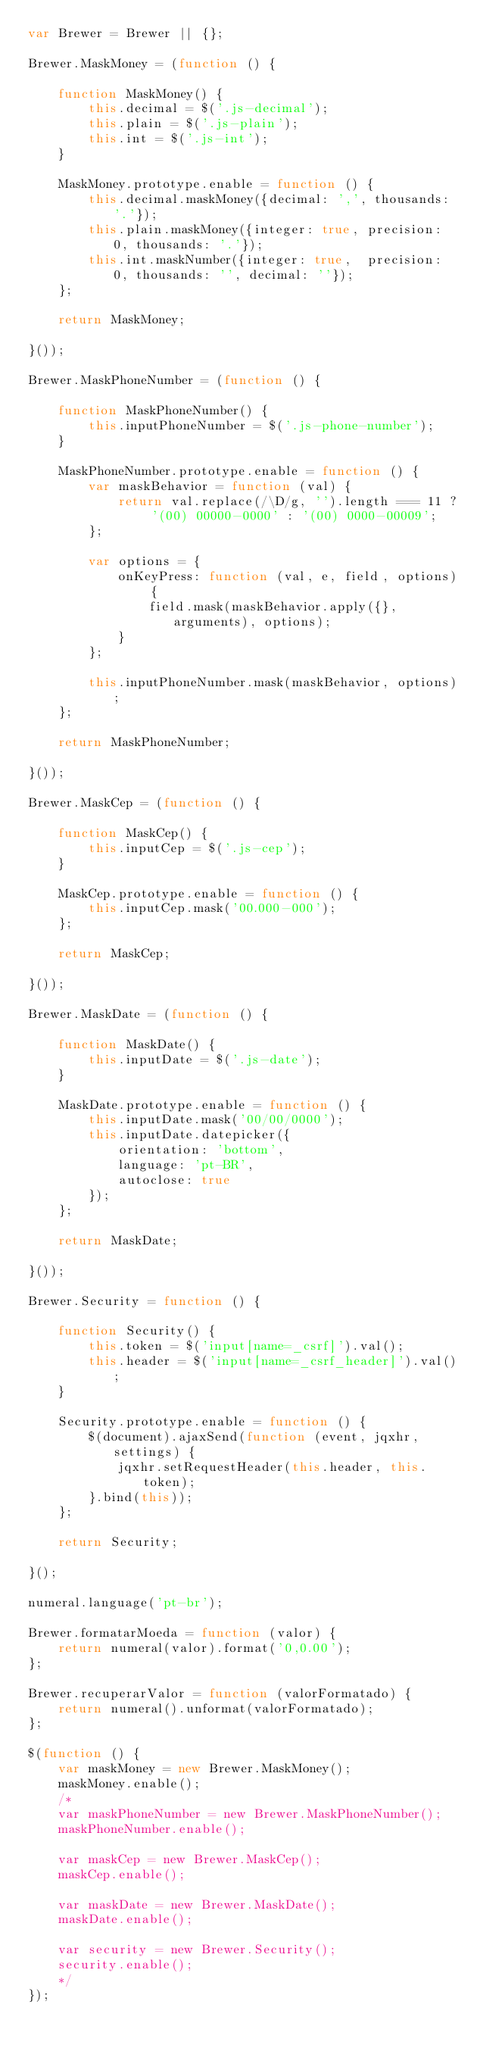Convert code to text. <code><loc_0><loc_0><loc_500><loc_500><_JavaScript_>var Brewer = Brewer || {};

Brewer.MaskMoney = (function () {

    function MaskMoney() {
        this.decimal = $('.js-decimal');
        this.plain = $('.js-plain');
        this.int = $('.js-int');
    }

    MaskMoney.prototype.enable = function () {
        this.decimal.maskMoney({decimal: ',', thousands: '.'});
        this.plain.maskMoney({integer: true, precision: 0, thousands: '.'});
        this.int.maskNumber({integer: true,  precision: 0, thousands: '', decimal: ''});
    };

    return MaskMoney;

}());

Brewer.MaskPhoneNumber = (function () {

    function MaskPhoneNumber() {
        this.inputPhoneNumber = $('.js-phone-number');
    }

    MaskPhoneNumber.prototype.enable = function () {
        var maskBehavior = function (val) {
            return val.replace(/\D/g, '').length === 11 ? '(00) 00000-0000' : '(00) 0000-00009';
        };

        var options = {
            onKeyPress: function (val, e, field, options) {
                field.mask(maskBehavior.apply({}, arguments), options);
            }
        };

        this.inputPhoneNumber.mask(maskBehavior, options);
    };

    return MaskPhoneNumber;

}());

Brewer.MaskCep = (function () {

    function MaskCep() {
        this.inputCep = $('.js-cep');
    }

    MaskCep.prototype.enable = function () {
        this.inputCep.mask('00.000-000');
    };

    return MaskCep;

}());

Brewer.MaskDate = (function () {

    function MaskDate() {
        this.inputDate = $('.js-date');
    }

    MaskDate.prototype.enable = function () {
        this.inputDate.mask('00/00/0000');
        this.inputDate.datepicker({
            orientation: 'bottom',
            language: 'pt-BR',
            autoclose: true
        });
    };

    return MaskDate;

}());

Brewer.Security = function () {

    function Security() {
        this.token = $('input[name=_csrf]').val();
        this.header = $('input[name=_csrf_header]').val();
    }

    Security.prototype.enable = function () {
        $(document).ajaxSend(function (event, jqxhr, settings) {
            jqxhr.setRequestHeader(this.header, this.token);
        }.bind(this));
    };

    return Security;

}();

numeral.language('pt-br');

Brewer.formatarMoeda = function (valor) {
    return numeral(valor).format('0,0.00');
};

Brewer.recuperarValor = function (valorFormatado) {
    return numeral().unformat(valorFormatado);
};

$(function () {
    var maskMoney = new Brewer.MaskMoney();
    maskMoney.enable();
    /*
    var maskPhoneNumber = new Brewer.MaskPhoneNumber();
    maskPhoneNumber.enable();

    var maskCep = new Brewer.MaskCep();
    maskCep.enable();

    var maskDate = new Brewer.MaskDate();
    maskDate.enable();

    var security = new Brewer.Security();
    security.enable();
    */
});
</code> 